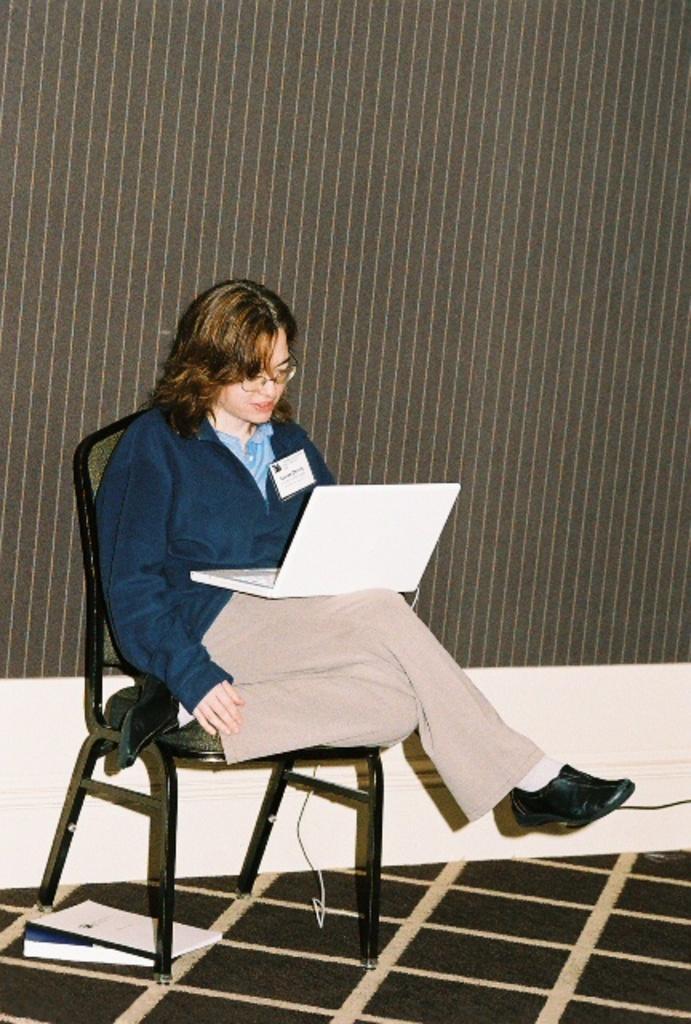In one or two sentences, can you explain what this image depicts? As we can see in the image there is a woman sitting on chair and holding laptop. 